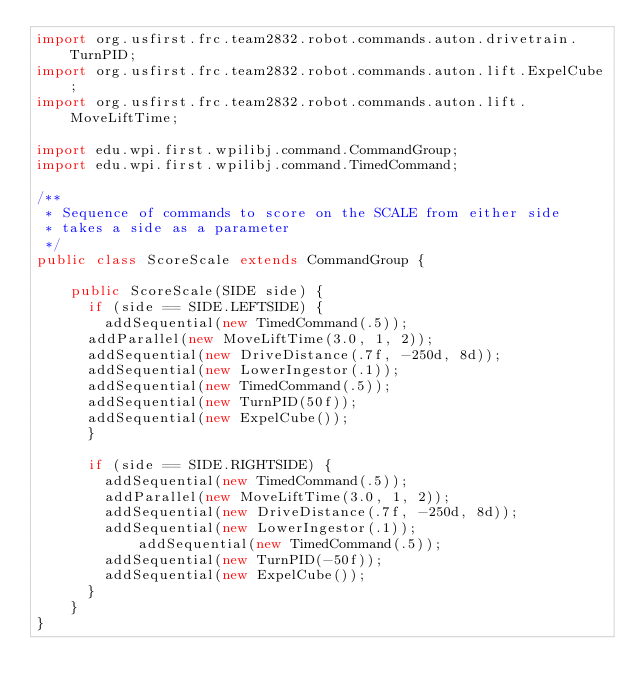<code> <loc_0><loc_0><loc_500><loc_500><_Java_>import org.usfirst.frc.team2832.robot.commands.auton.drivetrain.TurnPID;
import org.usfirst.frc.team2832.robot.commands.auton.lift.ExpelCube;
import org.usfirst.frc.team2832.robot.commands.auton.lift.MoveLiftTime;

import edu.wpi.first.wpilibj.command.CommandGroup;
import edu.wpi.first.wpilibj.command.TimedCommand;

/**
 * Sequence of commands to score on the SCALE from either side
 * takes a side as a parameter
 */
public class ScoreScale extends CommandGroup {

    public ScoreScale(SIDE side) {
    	if (side == SIDE.LEFTSIDE) {
    		addSequential(new TimedCommand(.5));
			addParallel(new MoveLiftTime(3.0, 1, 2));
			addSequential(new DriveDistance(.7f, -250d, 8d)); 
			addSequential(new LowerIngestor(.1));
			addSequential(new TimedCommand(.5));
			addSequential(new TurnPID(50f)); 
			addSequential(new ExpelCube());
    	}
    	
    	if (side == SIDE.RIGHTSIDE) {
    		addSequential(new TimedCommand(.5));
    		addParallel(new MoveLiftTime(3.0, 1, 2));
    		addSequential(new DriveDistance(.7f, -250d, 8d)); 
    		addSequential(new LowerIngestor(.1));
            addSequential(new TimedCommand(.5));
    		addSequential(new TurnPID(-50f));
    		addSequential(new ExpelCube());
    	}
    }
}
</code> 